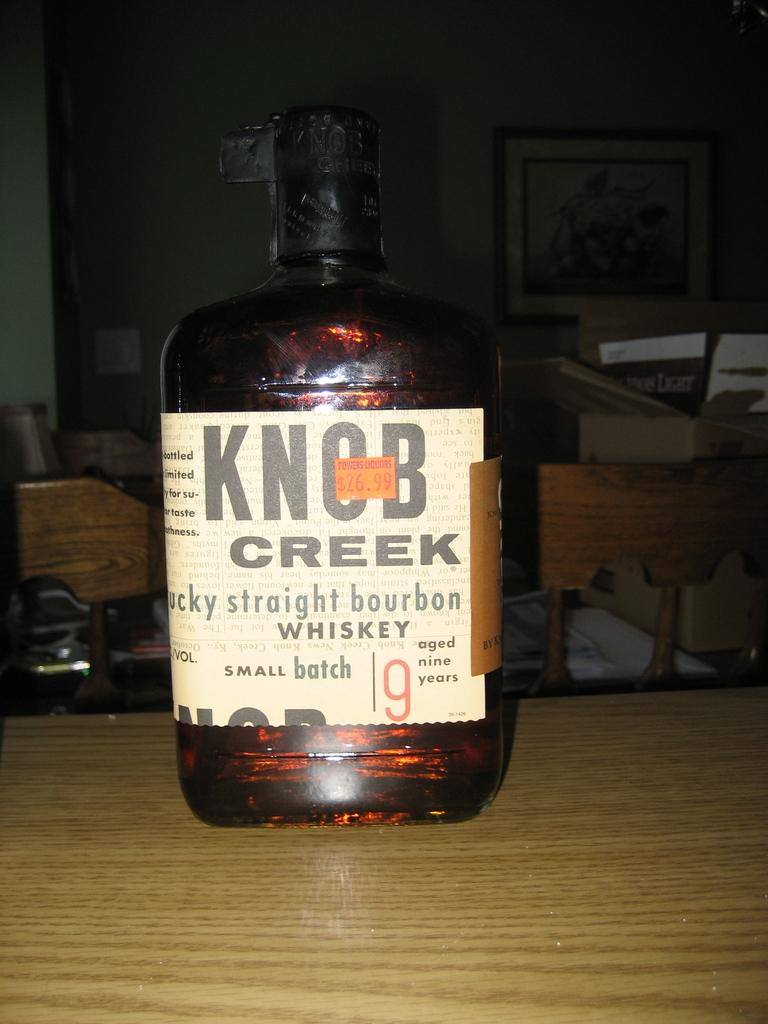<image>
Write a terse but informative summary of the picture. A full bottle of Knob Creek brand bourbon whiskey. 